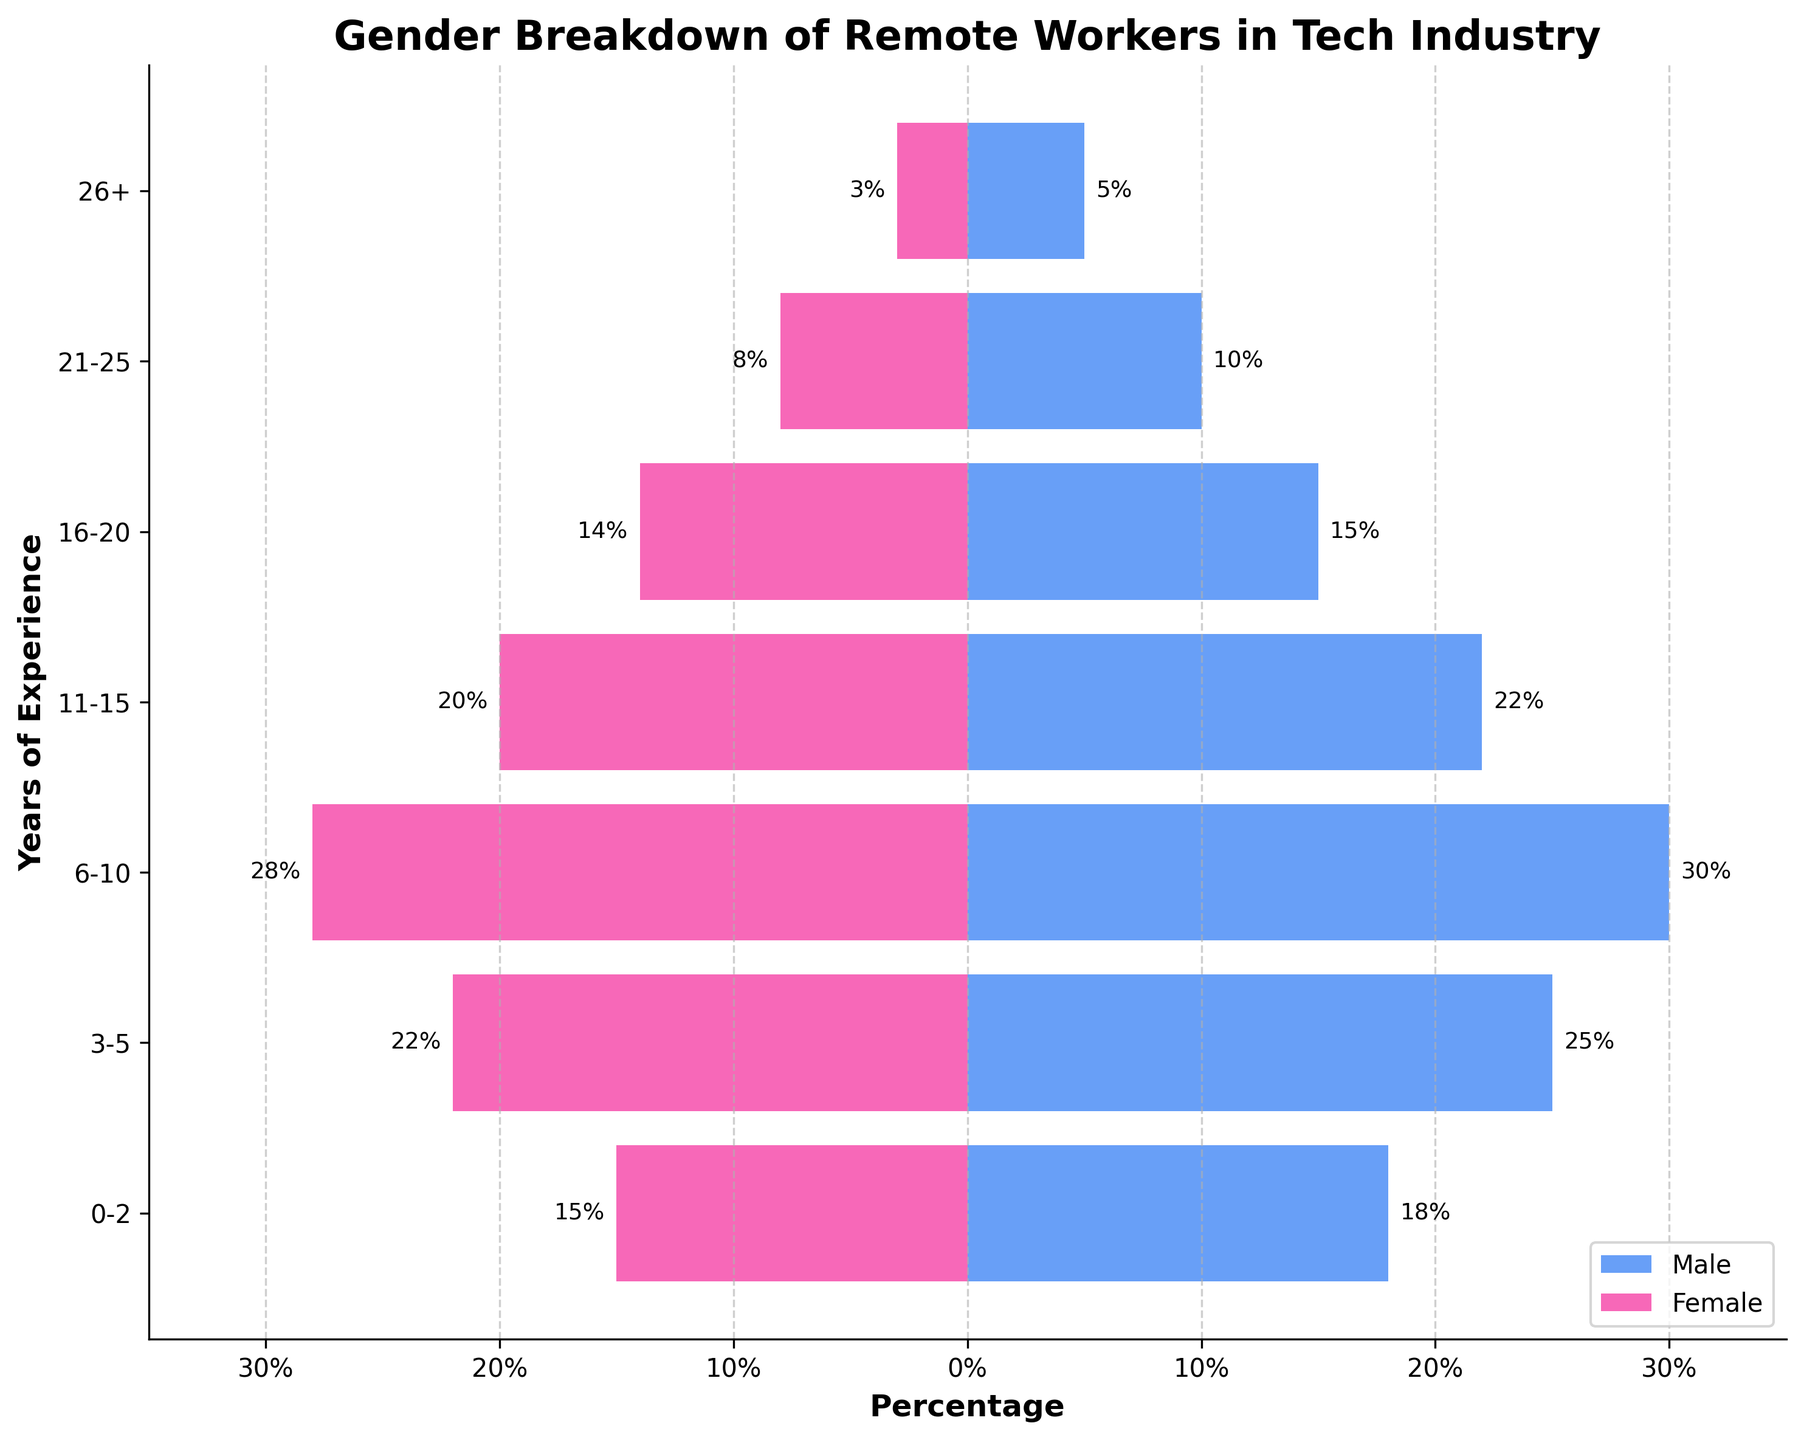What is the title of the figure? The title is located at the top of the figure and clearly indicates what the figure is about.
Answer: Gender Breakdown of Remote Workers in Tech Industry Which gender has more remote workers with 6-10 years of experience? From the bars corresponding to the 6-10 years of experience, compare the lengths of the bars for males and females. The male bar is longer.
Answer: Male What percentage of male remote workers has 16-20 years of experience? Locate the "16-20" years of experience bar for the male category, and read the number at the end of that bar.
Answer: 15% How many more female remote workers are there with 3-5 years of experience compared to female remote workers with 16-20 years of experience? The percentage of female remote workers with 3-5 years is 22%, and for 16-20 years, it is 14%. The difference is 22% - 14%.
Answer: 8% Between which years of experience range is the number of male remote workers the greatest? Compare the lengths of the male bars, and find the range with the longest bar.
Answer: 6-10 years What is the combined percentage of female remote workers in the 0-2 and 3-5 years of experience categories? Add the absolute values of percentages for females in 0-2 and 3-5 years: 15% + 22%.
Answer: 37% For the 21-25 years of experience range, which gender has a larger percentage of remote workers? Compare the lengths of the bars for both genders in the 21-25 years of experience range.
Answer: Male By how much does the percentage of male remote workers decrease from the 6-10 years range to the 26+ years range? Subtract the percentage for the 26+ years range (5%) from the percentage for the 6-10 years range (30%).
Answer: 25% What do the colors of the bars represent? Verify the legend at the bottom right of the figure to understand the color mapping. Blue represents males and pink represents females.
Answer: Males and Females 